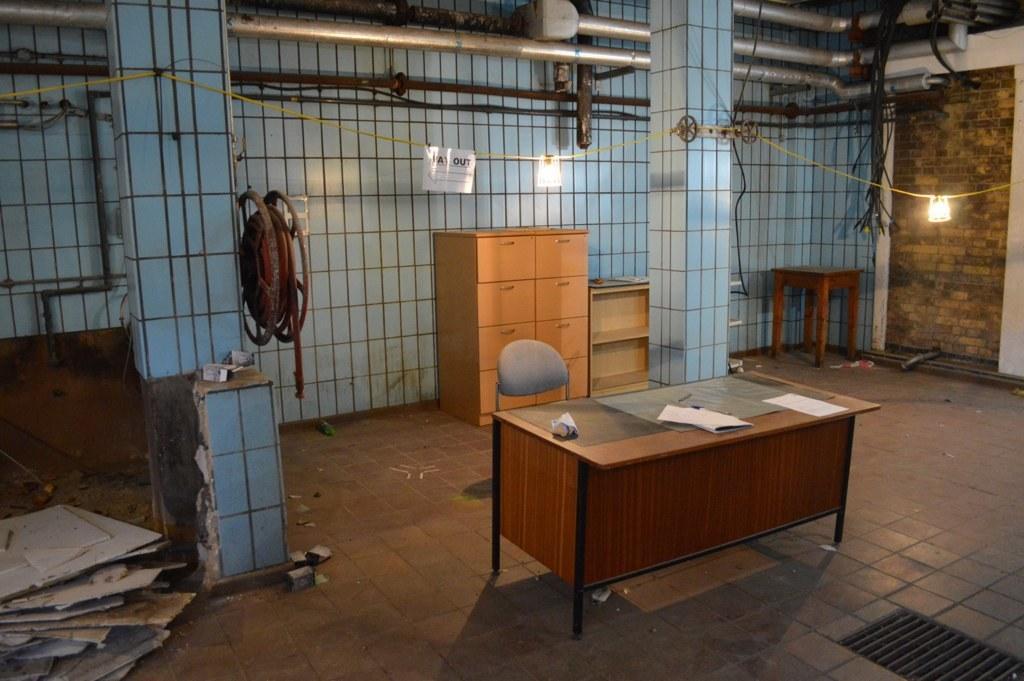Describe this image in one or two sentences. In the picture we can see a floor with a table on it we can see some papers and near it we can see a chair and in the background we can see two pillars and behind it we can see some wooden drawers and some racks near it and we can also see a light to the rope which is tied to the pillars. 